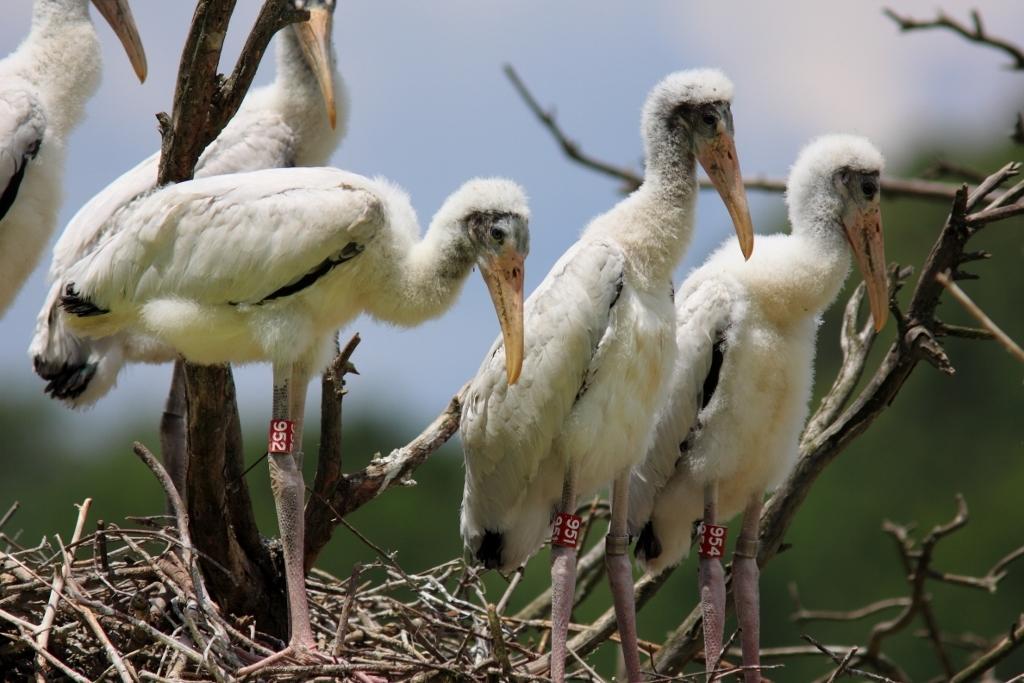Can you describe this image briefly? In this picture we can see there are birds and to the birds legs there are some stickers and behind the birds there are branches and a blurred background. 